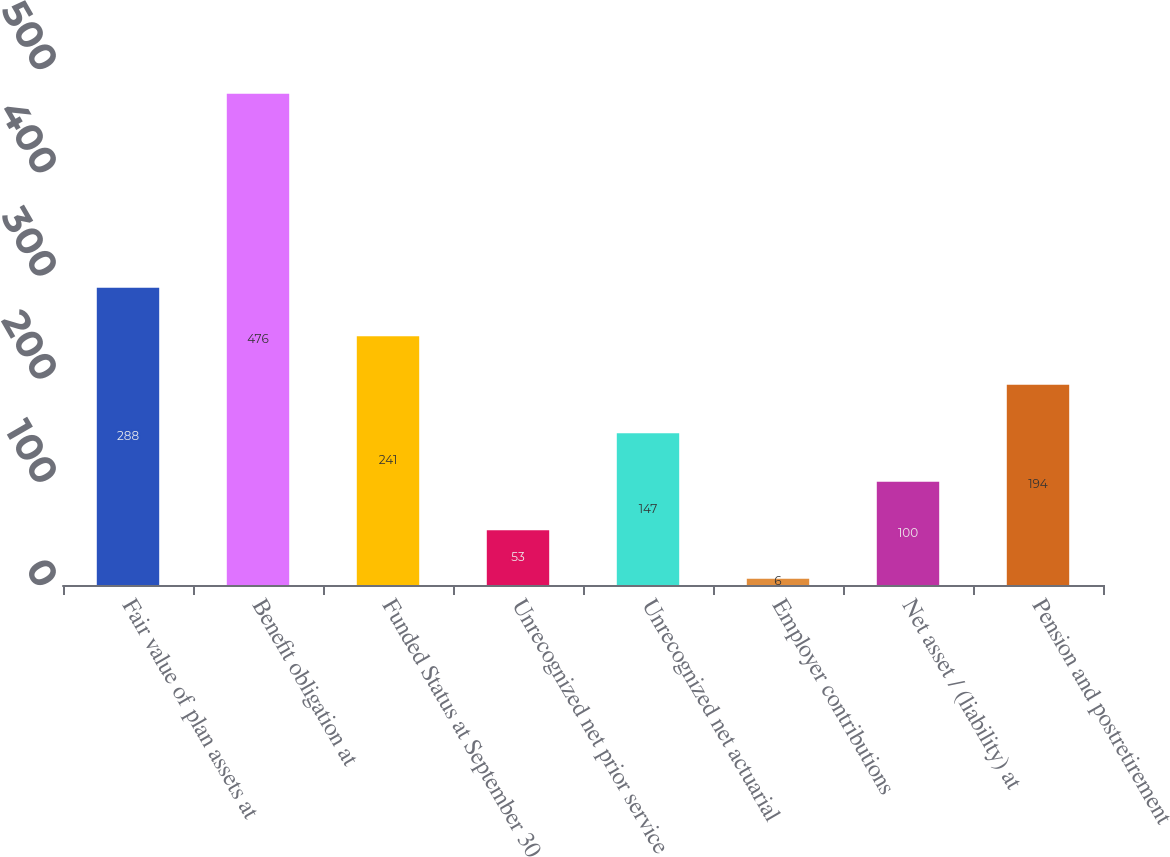<chart> <loc_0><loc_0><loc_500><loc_500><bar_chart><fcel>Fair value of plan assets at<fcel>Benefit obligation at<fcel>Funded Status at September 30<fcel>Unrecognized net prior service<fcel>Unrecognized net actuarial<fcel>Employer contributions<fcel>Net asset / (liability) at<fcel>Pension and postretirement<nl><fcel>288<fcel>476<fcel>241<fcel>53<fcel>147<fcel>6<fcel>100<fcel>194<nl></chart> 